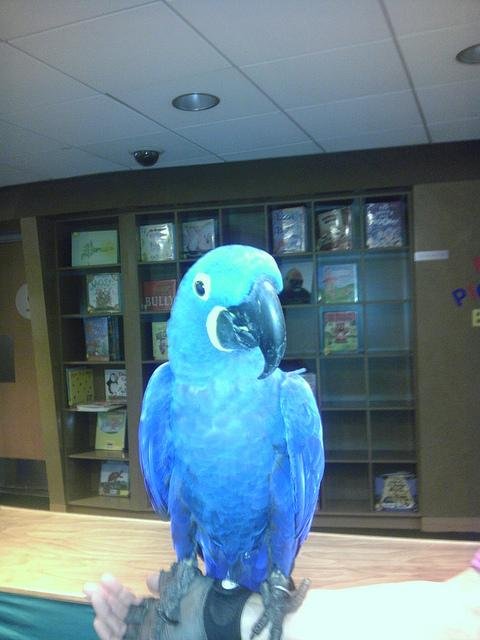Why is the person holding the bird wearing a glove?

Choices:
A) fashion
B) for work
C) warmth
D) protection protection 